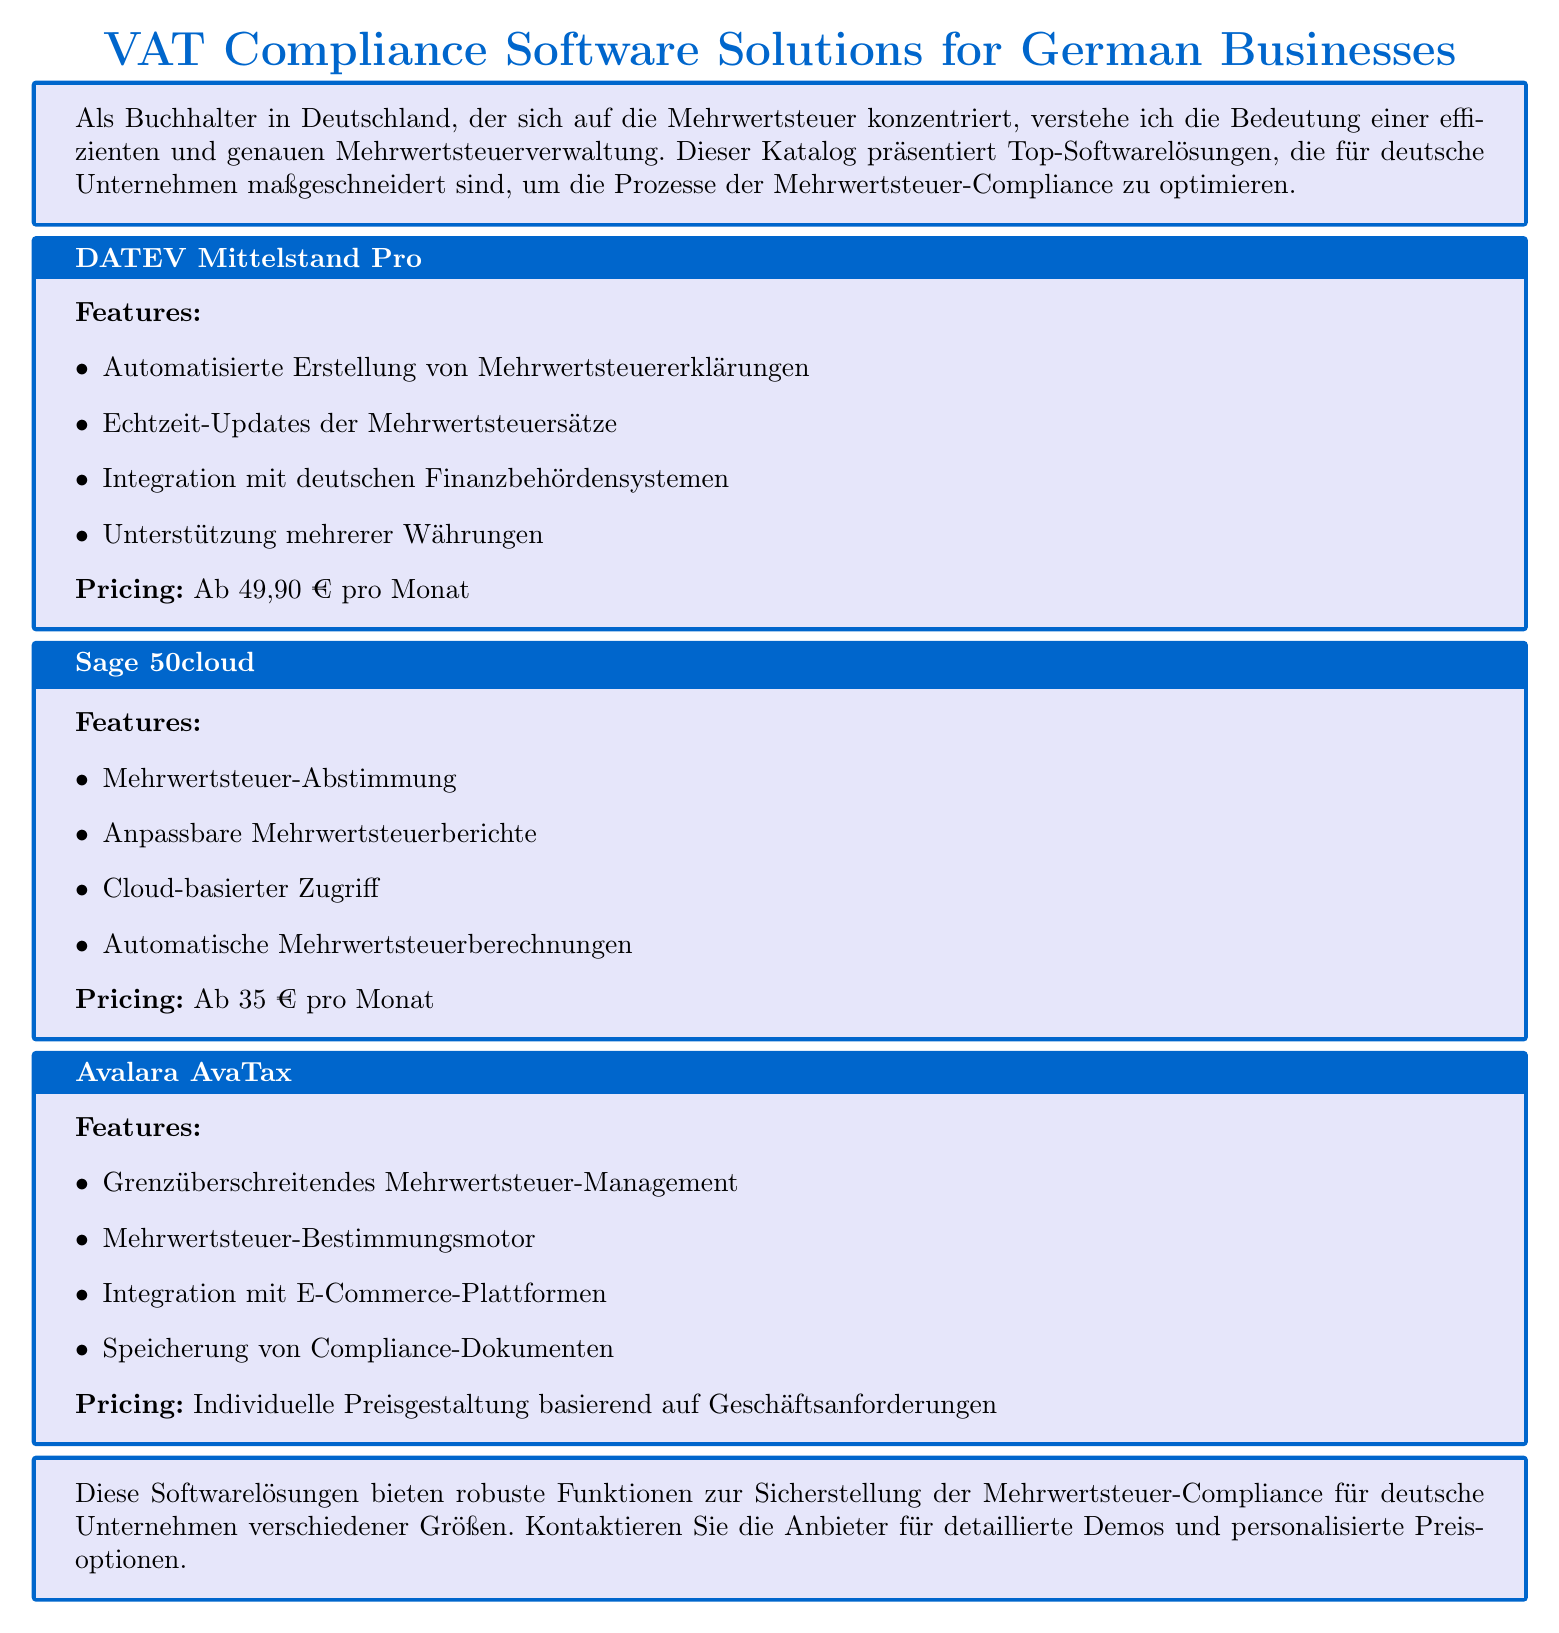Was ist der Preis von DATEV Mittelstand Pro? Der Preis wird im Katalog als "Ab 49,90 € pro Monat" angegeben.
Answer: Ab 49,90 € pro Monat Welche Funktion bietet Sage 50cloud bezüglich Mehrwertsteuer? In der Beschreibung steht, dass Sage 50cloud die Funktion "Mehrwertsteuer-Abstimmung" bietet.
Answer: Mehrwertsteuer-Abstimmung Was wird von Avalara AvaTax hinsichtlich der Compliance gespeichert? Im Katalog wird gesagt, dass "Speicherung von Compliance-Dokumenten" angeboten wird.
Answer: Speicherung von Compliance-Dokumenten Wie viele Softwarelösungen werden im Katalog vorgestellt? Es werden insgesamt drei Softwarelösungen erwähnt und beschrieben.
Answer: drei Bietet DATEV Mittelstand Pro Unterstützung für mehrere Währungen? Die Funktion wird im Katalog erwähnt, was bedeutet, dass Unterstützung für mehrere Währungen angeboten wird.
Answer: Ja Was beinhaltet die Funktionalität von Avalara AvaTax? Die Softwarelösung beinhaltet unter anderem "Grenzüberschreitendes Mehrwertsteuer-Management."
Answer: Grenzüberschreitendes Mehrwertsteuer-Management Welches Preismodell hat Avalara AvaTax? Der Katalog erwähnt, dass Avalara AvaTax eine "Individuelle Preisgestaltung" hat.
Answer: Individuelle Preisgestaltung Hat Sage 50cloud einen Cloud-basierten Zugriff? In der Beschreibung von Sage 50cloud wird dies explizit erwähnt.
Answer: Ja Wie werden die Mehrwertsteuersätze bei DATEV Mittelstand Pro aktualisiert? "Echtzeit-Updates der Mehrwertsteuersätze" wird in den Funktionen aufgeführt.
Answer: Echtzeit-Updates der Mehrwertsteuersätze 